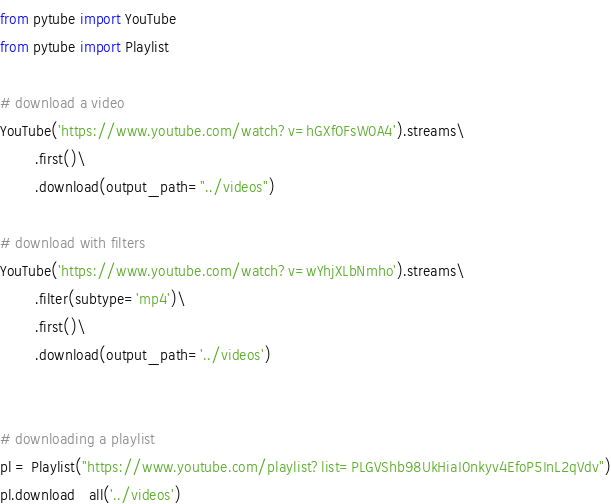<code> <loc_0><loc_0><loc_500><loc_500><_Python_>from pytube import YouTube
from pytube import Playlist

# download a video
YouTube('https://www.youtube.com/watch?v=hGXf0FsW0A4').streams\
        .first()\
        .download(output_path="../videos")

# download with filters
YouTube('https://www.youtube.com/watch?v=wYhjXLbNmho').streams\
        .filter(subtype='mp4')\
        .first()\
        .download(output_path='../videos')


# downloading a playlist
pl = Playlist("https://www.youtube.com/playlist?list=PLGVShb98UkHiaI0nkyv4EfoP5InL2qVdv")
pl.download_all('../videos')</code> 